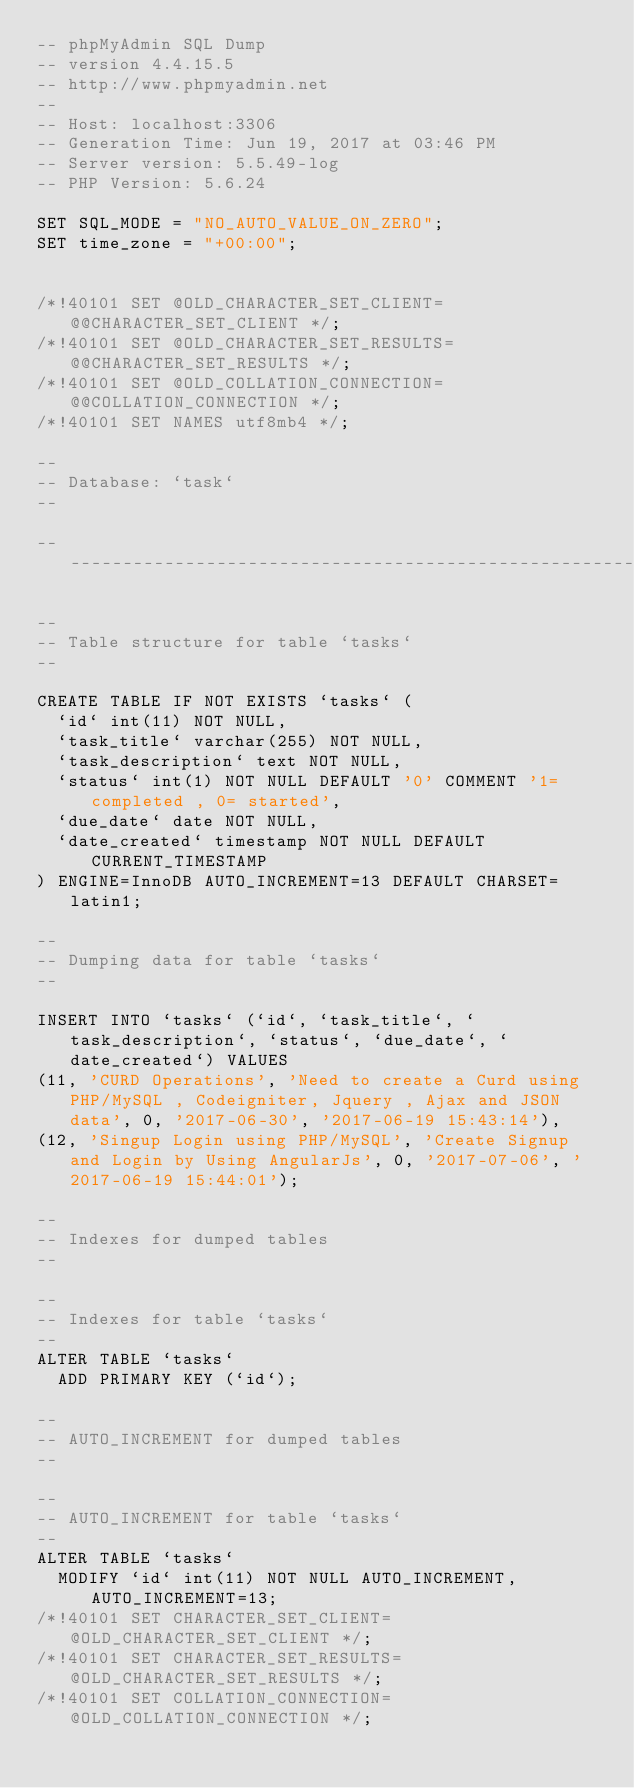Convert code to text. <code><loc_0><loc_0><loc_500><loc_500><_SQL_>-- phpMyAdmin SQL Dump
-- version 4.4.15.5
-- http://www.phpmyadmin.net
--
-- Host: localhost:3306
-- Generation Time: Jun 19, 2017 at 03:46 PM
-- Server version: 5.5.49-log
-- PHP Version: 5.6.24

SET SQL_MODE = "NO_AUTO_VALUE_ON_ZERO";
SET time_zone = "+00:00";


/*!40101 SET @OLD_CHARACTER_SET_CLIENT=@@CHARACTER_SET_CLIENT */;
/*!40101 SET @OLD_CHARACTER_SET_RESULTS=@@CHARACTER_SET_RESULTS */;
/*!40101 SET @OLD_COLLATION_CONNECTION=@@COLLATION_CONNECTION */;
/*!40101 SET NAMES utf8mb4 */;

--
-- Database: `task`
--

-- --------------------------------------------------------

--
-- Table structure for table `tasks`
--

CREATE TABLE IF NOT EXISTS `tasks` (
  `id` int(11) NOT NULL,
  `task_title` varchar(255) NOT NULL,
  `task_description` text NOT NULL,
  `status` int(1) NOT NULL DEFAULT '0' COMMENT '1=completed , 0= started',
  `due_date` date NOT NULL,
  `date_created` timestamp NOT NULL DEFAULT CURRENT_TIMESTAMP
) ENGINE=InnoDB AUTO_INCREMENT=13 DEFAULT CHARSET=latin1;

--
-- Dumping data for table `tasks`
--

INSERT INTO `tasks` (`id`, `task_title`, `task_description`, `status`, `due_date`, `date_created`) VALUES
(11, 'CURD Operations', 'Need to create a Curd using PHP/MySQL , Codeigniter, Jquery , Ajax and JSON data', 0, '2017-06-30', '2017-06-19 15:43:14'),
(12, 'Singup Login using PHP/MySQL', 'Create Signup and Login by Using AngularJs', 0, '2017-07-06', '2017-06-19 15:44:01');

--
-- Indexes for dumped tables
--

--
-- Indexes for table `tasks`
--
ALTER TABLE `tasks`
  ADD PRIMARY KEY (`id`);

--
-- AUTO_INCREMENT for dumped tables
--

--
-- AUTO_INCREMENT for table `tasks`
--
ALTER TABLE `tasks`
  MODIFY `id` int(11) NOT NULL AUTO_INCREMENT,AUTO_INCREMENT=13;
/*!40101 SET CHARACTER_SET_CLIENT=@OLD_CHARACTER_SET_CLIENT */;
/*!40101 SET CHARACTER_SET_RESULTS=@OLD_CHARACTER_SET_RESULTS */;
/*!40101 SET COLLATION_CONNECTION=@OLD_COLLATION_CONNECTION */;
</code> 